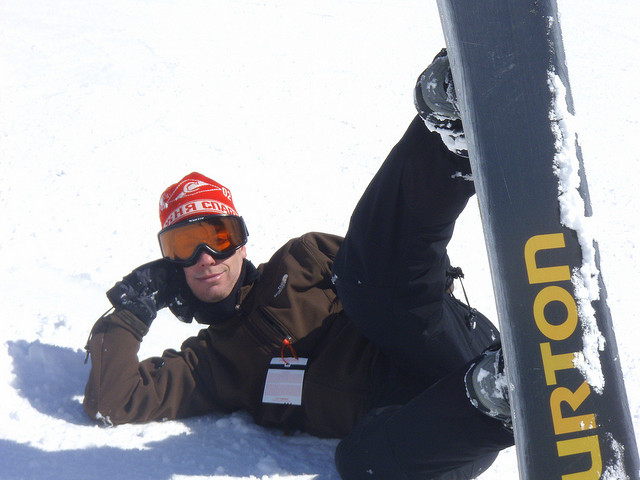Read all the text in this image. URTON R H C 02 